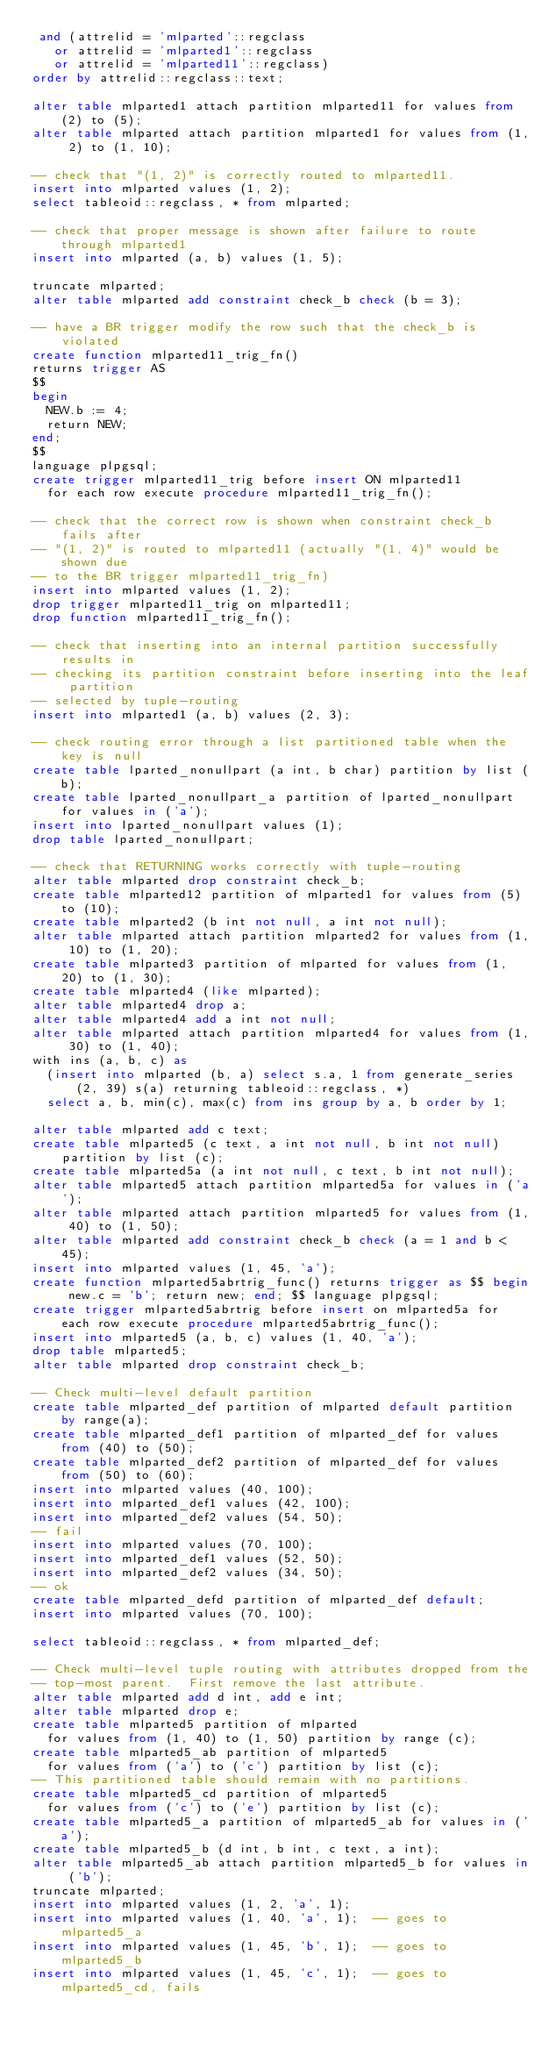<code> <loc_0><loc_0><loc_500><loc_500><_SQL_> and (attrelid = 'mlparted'::regclass
   or attrelid = 'mlparted1'::regclass
   or attrelid = 'mlparted11'::regclass)
order by attrelid::regclass::text;

alter table mlparted1 attach partition mlparted11 for values from (2) to (5);
alter table mlparted attach partition mlparted1 for values from (1, 2) to (1, 10);

-- check that "(1, 2)" is correctly routed to mlparted11.
insert into mlparted values (1, 2);
select tableoid::regclass, * from mlparted;

-- check that proper message is shown after failure to route through mlparted1
insert into mlparted (a, b) values (1, 5);

truncate mlparted;
alter table mlparted add constraint check_b check (b = 3);

-- have a BR trigger modify the row such that the check_b is violated
create function mlparted11_trig_fn()
returns trigger AS
$$
begin
  NEW.b := 4;
  return NEW;
end;
$$
language plpgsql;
create trigger mlparted11_trig before insert ON mlparted11
  for each row execute procedure mlparted11_trig_fn();

-- check that the correct row is shown when constraint check_b fails after
-- "(1, 2)" is routed to mlparted11 (actually "(1, 4)" would be shown due
-- to the BR trigger mlparted11_trig_fn)
insert into mlparted values (1, 2);
drop trigger mlparted11_trig on mlparted11;
drop function mlparted11_trig_fn();

-- check that inserting into an internal partition successfully results in
-- checking its partition constraint before inserting into the leaf partition
-- selected by tuple-routing
insert into mlparted1 (a, b) values (2, 3);

-- check routing error through a list partitioned table when the key is null
create table lparted_nonullpart (a int, b char) partition by list (b);
create table lparted_nonullpart_a partition of lparted_nonullpart for values in ('a');
insert into lparted_nonullpart values (1);
drop table lparted_nonullpart;

-- check that RETURNING works correctly with tuple-routing
alter table mlparted drop constraint check_b;
create table mlparted12 partition of mlparted1 for values from (5) to (10);
create table mlparted2 (b int not null, a int not null);
alter table mlparted attach partition mlparted2 for values from (1, 10) to (1, 20);
create table mlparted3 partition of mlparted for values from (1, 20) to (1, 30);
create table mlparted4 (like mlparted);
alter table mlparted4 drop a;
alter table mlparted4 add a int not null;
alter table mlparted attach partition mlparted4 for values from (1, 30) to (1, 40);
with ins (a, b, c) as
  (insert into mlparted (b, a) select s.a, 1 from generate_series(2, 39) s(a) returning tableoid::regclass, *)
  select a, b, min(c), max(c) from ins group by a, b order by 1;

alter table mlparted add c text;
create table mlparted5 (c text, a int not null, b int not null) partition by list (c);
create table mlparted5a (a int not null, c text, b int not null);
alter table mlparted5 attach partition mlparted5a for values in ('a');
alter table mlparted attach partition mlparted5 for values from (1, 40) to (1, 50);
alter table mlparted add constraint check_b check (a = 1 and b < 45);
insert into mlparted values (1, 45, 'a');
create function mlparted5abrtrig_func() returns trigger as $$ begin new.c = 'b'; return new; end; $$ language plpgsql;
create trigger mlparted5abrtrig before insert on mlparted5a for each row execute procedure mlparted5abrtrig_func();
insert into mlparted5 (a, b, c) values (1, 40, 'a');
drop table mlparted5;
alter table mlparted drop constraint check_b;

-- Check multi-level default partition
create table mlparted_def partition of mlparted default partition by range(a);
create table mlparted_def1 partition of mlparted_def for values from (40) to (50);
create table mlparted_def2 partition of mlparted_def for values from (50) to (60);
insert into mlparted values (40, 100);
insert into mlparted_def1 values (42, 100);
insert into mlparted_def2 values (54, 50);
-- fail
insert into mlparted values (70, 100);
insert into mlparted_def1 values (52, 50);
insert into mlparted_def2 values (34, 50);
-- ok
create table mlparted_defd partition of mlparted_def default;
insert into mlparted values (70, 100);

select tableoid::regclass, * from mlparted_def;

-- Check multi-level tuple routing with attributes dropped from the
-- top-most parent.  First remove the last attribute.
alter table mlparted add d int, add e int;
alter table mlparted drop e;
create table mlparted5 partition of mlparted
  for values from (1, 40) to (1, 50) partition by range (c);
create table mlparted5_ab partition of mlparted5
  for values from ('a') to ('c') partition by list (c);
-- This partitioned table should remain with no partitions.
create table mlparted5_cd partition of mlparted5
  for values from ('c') to ('e') partition by list (c);
create table mlparted5_a partition of mlparted5_ab for values in ('a');
create table mlparted5_b (d int, b int, c text, a int);
alter table mlparted5_ab attach partition mlparted5_b for values in ('b');
truncate mlparted;
insert into mlparted values (1, 2, 'a', 1);
insert into mlparted values (1, 40, 'a', 1);  -- goes to mlparted5_a
insert into mlparted values (1, 45, 'b', 1);  -- goes to mlparted5_b
insert into mlparted values (1, 45, 'c', 1);  -- goes to mlparted5_cd, fails</code> 